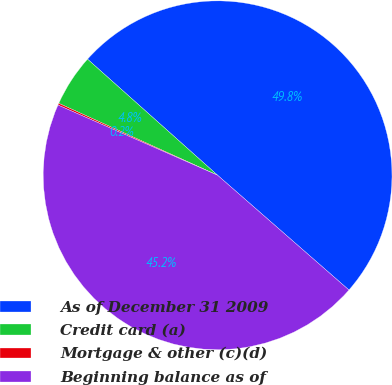<chart> <loc_0><loc_0><loc_500><loc_500><pie_chart><fcel>As of December 31 2009<fcel>Credit card (a)<fcel>Mortgage & other (c)(d)<fcel>Beginning balance as of<nl><fcel>49.83%<fcel>4.83%<fcel>0.17%<fcel>45.17%<nl></chart> 